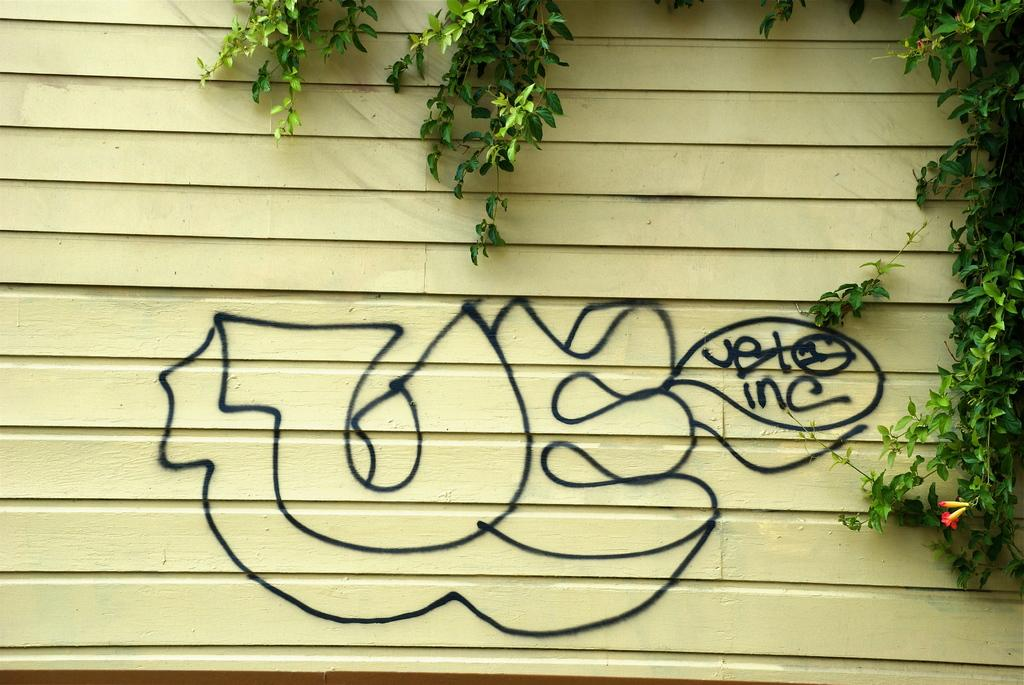What is present on the wall in the image? There is graffiti on the wall in the image. What type of vegetation is visible in the image? Green leaves are visible at the top and on the right side of the image. What advice is given by the graffiti in the image? The graffiti does not provide any advice in the image; it is simply an artistic expression on the wall. 